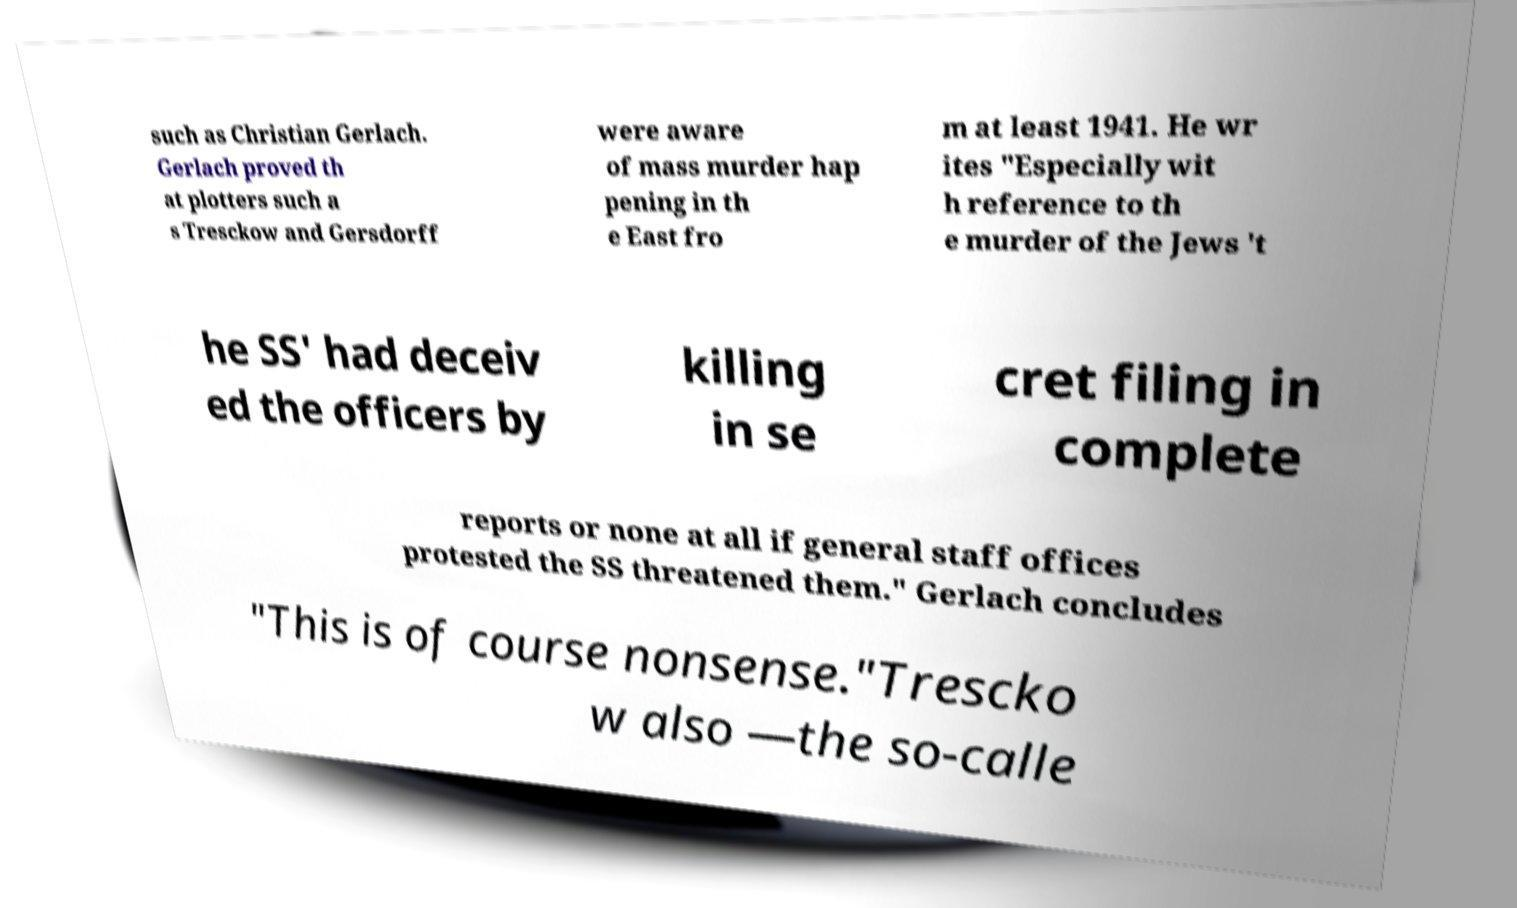Please read and relay the text visible in this image. What does it say? such as Christian Gerlach. Gerlach proved th at plotters such a s Tresckow and Gersdorff were aware of mass murder hap pening in th e East fro m at least 1941. He wr ites "Especially wit h reference to th e murder of the Jews 't he SS' had deceiv ed the officers by killing in se cret filing in complete reports or none at all if general staff offices protested the SS threatened them." Gerlach concludes "This is of course nonsense."Trescko w also —the so-calle 